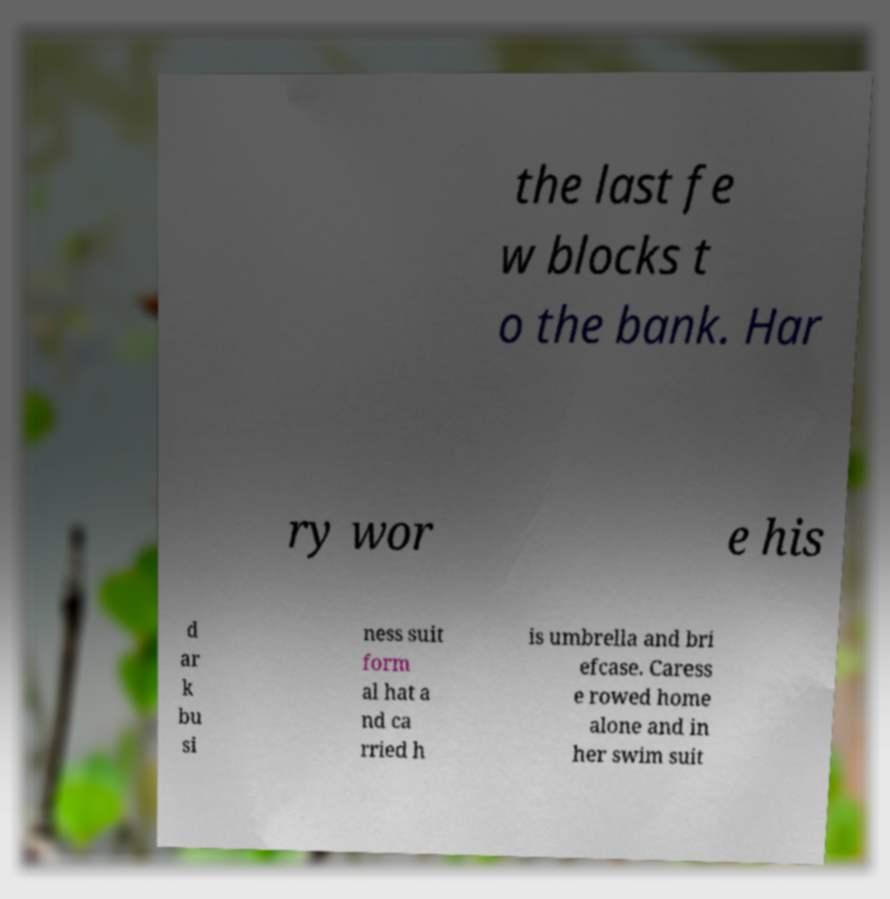What messages or text are displayed in this image? I need them in a readable, typed format. the last fe w blocks t o the bank. Har ry wor e his d ar k bu si ness suit form al hat a nd ca rried h is umbrella and bri efcase. Caress e rowed home alone and in her swim suit 